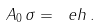<formula> <loc_0><loc_0><loc_500><loc_500>A _ { 0 } \, \sigma = \ e h \, .</formula> 